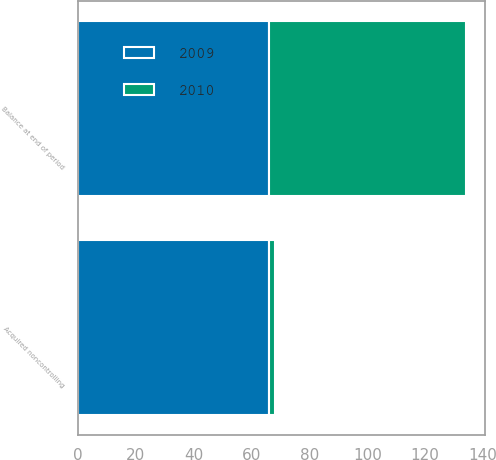Convert chart to OTSL. <chart><loc_0><loc_0><loc_500><loc_500><stacked_bar_chart><ecel><fcel>Acquired noncontrolling<fcel>Balance at end of period<nl><fcel>2010<fcel>2<fcel>68<nl><fcel>2009<fcel>66<fcel>66<nl></chart> 